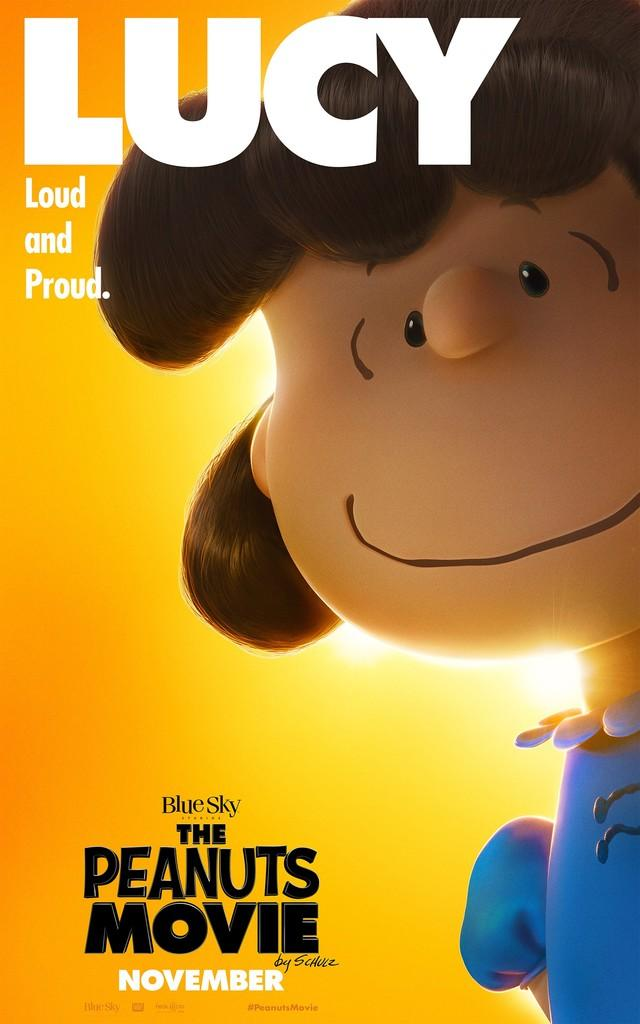<image>
Give a short and clear explanation of the subsequent image. The Peanuts Movie poster shows Lucy on it. 